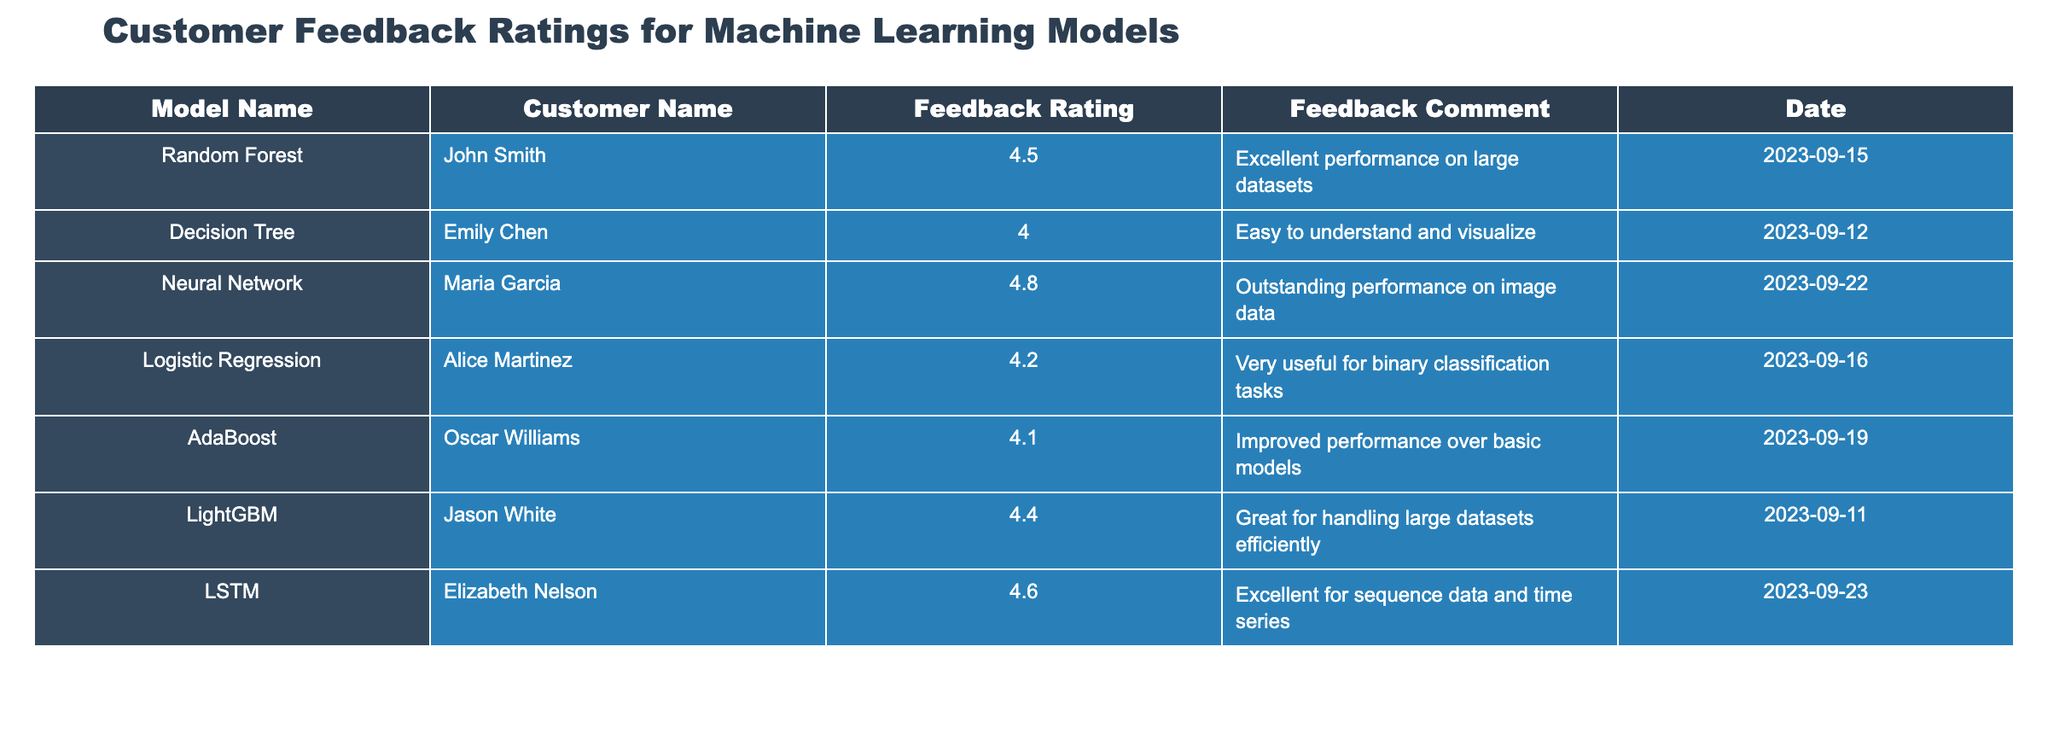What is the highest feedback rating among the models? The table shows feedback ratings for each model. The highest rating listed is 4.8 for the Neural Network model.
Answer: 4.8 Which model was rated the lowest by a customer? By examining the ratings in the table, the lowest feedback rating is 4.0, attributed to the Decision Tree model.
Answer: Decision Tree How many models received a rating of 4.5 or higher? Counting the ratings of 4.5 and above, they are: 4.5 (Random Forest), 4.8 (Neural Network), 4.6 (LSTM), and 4.4 (LightGBM). This totals 4 models.
Answer: 4 What is the average feedback rating for all the models? To calculate the average, sum all the ratings: 4.5 + 4.0 + 4.8 + 4.2 + 4.1 + 4.4 + 4.6 = 26.6. There are 7 models, so the average rating is 26.6 / 7 = 3.8 (rounded to one decimal).
Answer: 3.8 Did any model receive a rating of 4.1 or lower? Analyzing the ratings, the AdaBoost model received a rating of 4.1, which is exactly at the cutoff, making the statement true.
Answer: Yes Which customer provided the comment about "Excellent for sequence data and time series"? The comment "Excellent for sequence data and time series" was given by Elizabeth Nelson regarding the LSTM model.
Answer: Elizabeth Nelson Is the feedback date for the model "Random Forest" earlier than that for the "Neural Network"? The "Random Forest" model has a feedback date of 2023-09-15 and the "Neural Network" has a date of 2023-09-22, which indicates that Random Forest's date is earlier.
Answer: Yes How many customers provided feedback for each model? Each model is reviewed by one customer, so for the 7 models listed, there are 7 individual feedback entries in total.
Answer: 1 per model (7 total) Which feedback comment corresponds to the model with the second highest rating? The second highest rating is 4.6, which corresponds to the LSTM model with the comment "Excellent for sequence data and time series."
Answer: Excellent for sequence data and time series What was the feedback comment for the model rated 4.4? Looking at the table, the LightGBM model received a rating of 4.4 with the comment "Great for handling large datasets efficiently."
Answer: Great for handling large datasets efficiently 